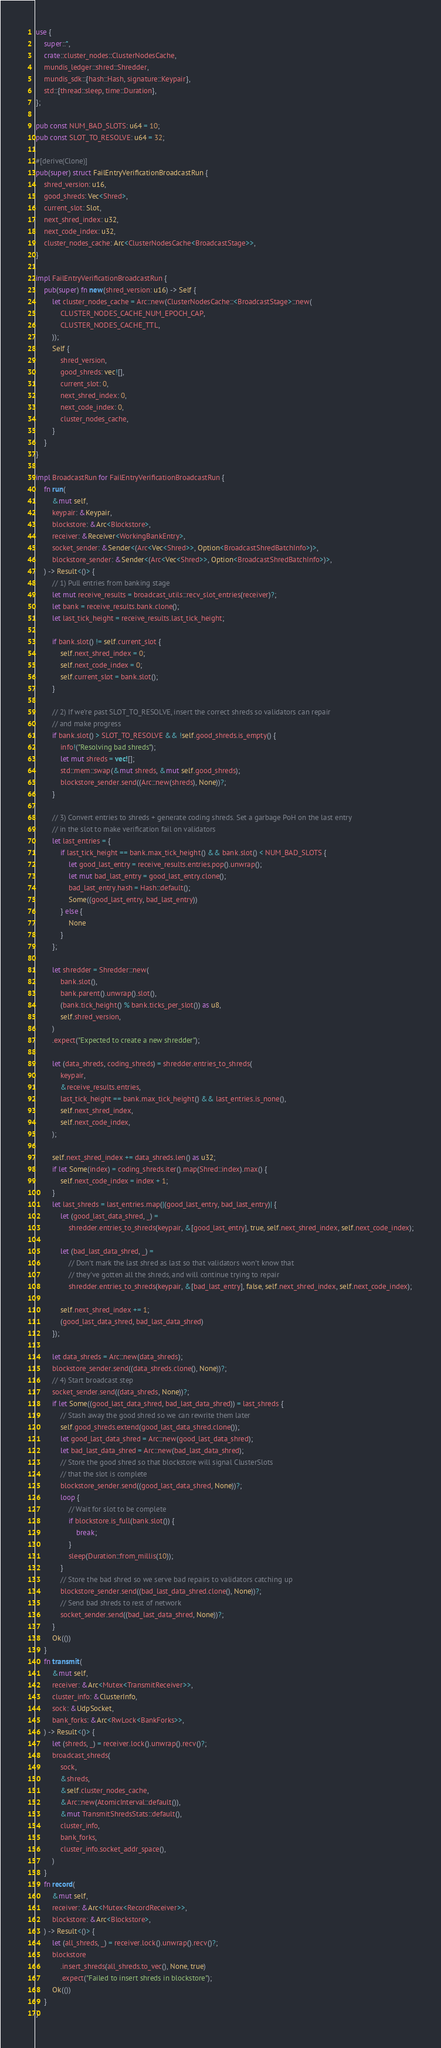<code> <loc_0><loc_0><loc_500><loc_500><_Rust_>use {
    super::*,
    crate::cluster_nodes::ClusterNodesCache,
    mundis_ledger::shred::Shredder,
    mundis_sdk::{hash::Hash, signature::Keypair},
    std::{thread::sleep, time::Duration},
};

pub const NUM_BAD_SLOTS: u64 = 10;
pub const SLOT_TO_RESOLVE: u64 = 32;

#[derive(Clone)]
pub(super) struct FailEntryVerificationBroadcastRun {
    shred_version: u16,
    good_shreds: Vec<Shred>,
    current_slot: Slot,
    next_shred_index: u32,
    next_code_index: u32,
    cluster_nodes_cache: Arc<ClusterNodesCache<BroadcastStage>>,
}

impl FailEntryVerificationBroadcastRun {
    pub(super) fn new(shred_version: u16) -> Self {
        let cluster_nodes_cache = Arc::new(ClusterNodesCache::<BroadcastStage>::new(
            CLUSTER_NODES_CACHE_NUM_EPOCH_CAP,
            CLUSTER_NODES_CACHE_TTL,
        ));
        Self {
            shred_version,
            good_shreds: vec![],
            current_slot: 0,
            next_shred_index: 0,
            next_code_index: 0,
            cluster_nodes_cache,
        }
    }
}

impl BroadcastRun for FailEntryVerificationBroadcastRun {
    fn run(
        &mut self,
        keypair: &Keypair,
        blockstore: &Arc<Blockstore>,
        receiver: &Receiver<WorkingBankEntry>,
        socket_sender: &Sender<(Arc<Vec<Shred>>, Option<BroadcastShredBatchInfo>)>,
        blockstore_sender: &Sender<(Arc<Vec<Shred>>, Option<BroadcastShredBatchInfo>)>,
    ) -> Result<()> {
        // 1) Pull entries from banking stage
        let mut receive_results = broadcast_utils::recv_slot_entries(receiver)?;
        let bank = receive_results.bank.clone();
        let last_tick_height = receive_results.last_tick_height;

        if bank.slot() != self.current_slot {
            self.next_shred_index = 0;
            self.next_code_index = 0;
            self.current_slot = bank.slot();
        }

        // 2) If we're past SLOT_TO_RESOLVE, insert the correct shreds so validators can repair
        // and make progress
        if bank.slot() > SLOT_TO_RESOLVE && !self.good_shreds.is_empty() {
            info!("Resolving bad shreds");
            let mut shreds = vec![];
            std::mem::swap(&mut shreds, &mut self.good_shreds);
            blockstore_sender.send((Arc::new(shreds), None))?;
        }

        // 3) Convert entries to shreds + generate coding shreds. Set a garbage PoH on the last entry
        // in the slot to make verification fail on validators
        let last_entries = {
            if last_tick_height == bank.max_tick_height() && bank.slot() < NUM_BAD_SLOTS {
                let good_last_entry = receive_results.entries.pop().unwrap();
                let mut bad_last_entry = good_last_entry.clone();
                bad_last_entry.hash = Hash::default();
                Some((good_last_entry, bad_last_entry))
            } else {
                None
            }
        };

        let shredder = Shredder::new(
            bank.slot(),
            bank.parent().unwrap().slot(),
            (bank.tick_height() % bank.ticks_per_slot()) as u8,
            self.shred_version,
        )
        .expect("Expected to create a new shredder");

        let (data_shreds, coding_shreds) = shredder.entries_to_shreds(
            keypair,
            &receive_results.entries,
            last_tick_height == bank.max_tick_height() && last_entries.is_none(),
            self.next_shred_index,
            self.next_code_index,
        );

        self.next_shred_index += data_shreds.len() as u32;
        if let Some(index) = coding_shreds.iter().map(Shred::index).max() {
            self.next_code_index = index + 1;
        }
        let last_shreds = last_entries.map(|(good_last_entry, bad_last_entry)| {
            let (good_last_data_shred, _) =
                shredder.entries_to_shreds(keypair, &[good_last_entry], true, self.next_shred_index, self.next_code_index);

            let (bad_last_data_shred, _) =
                // Don't mark the last shred as last so that validators won't know that
                // they've gotten all the shreds, and will continue trying to repair
                shredder.entries_to_shreds(keypair, &[bad_last_entry], false, self.next_shred_index, self.next_code_index);

            self.next_shred_index += 1;
            (good_last_data_shred, bad_last_data_shred)
        });

        let data_shreds = Arc::new(data_shreds);
        blockstore_sender.send((data_shreds.clone(), None))?;
        // 4) Start broadcast step
        socket_sender.send((data_shreds, None))?;
        if let Some((good_last_data_shred, bad_last_data_shred)) = last_shreds {
            // Stash away the good shred so we can rewrite them later
            self.good_shreds.extend(good_last_data_shred.clone());
            let good_last_data_shred = Arc::new(good_last_data_shred);
            let bad_last_data_shred = Arc::new(bad_last_data_shred);
            // Store the good shred so that blockstore will signal ClusterSlots
            // that the slot is complete
            blockstore_sender.send((good_last_data_shred, None))?;
            loop {
                // Wait for slot to be complete
                if blockstore.is_full(bank.slot()) {
                    break;
                }
                sleep(Duration::from_millis(10));
            }
            // Store the bad shred so we serve bad repairs to validators catching up
            blockstore_sender.send((bad_last_data_shred.clone(), None))?;
            // Send bad shreds to rest of network
            socket_sender.send((bad_last_data_shred, None))?;
        }
        Ok(())
    }
    fn transmit(
        &mut self,
        receiver: &Arc<Mutex<TransmitReceiver>>,
        cluster_info: &ClusterInfo,
        sock: &UdpSocket,
        bank_forks: &Arc<RwLock<BankForks>>,
    ) -> Result<()> {
        let (shreds, _) = receiver.lock().unwrap().recv()?;
        broadcast_shreds(
            sock,
            &shreds,
            &self.cluster_nodes_cache,
            &Arc::new(AtomicInterval::default()),
            &mut TransmitShredsStats::default(),
            cluster_info,
            bank_forks,
            cluster_info.socket_addr_space(),
        )
    }
    fn record(
        &mut self,
        receiver: &Arc<Mutex<RecordReceiver>>,
        blockstore: &Arc<Blockstore>,
    ) -> Result<()> {
        let (all_shreds, _) = receiver.lock().unwrap().recv()?;
        blockstore
            .insert_shreds(all_shreds.to_vec(), None, true)
            .expect("Failed to insert shreds in blockstore");
        Ok(())
    }
}
</code> 